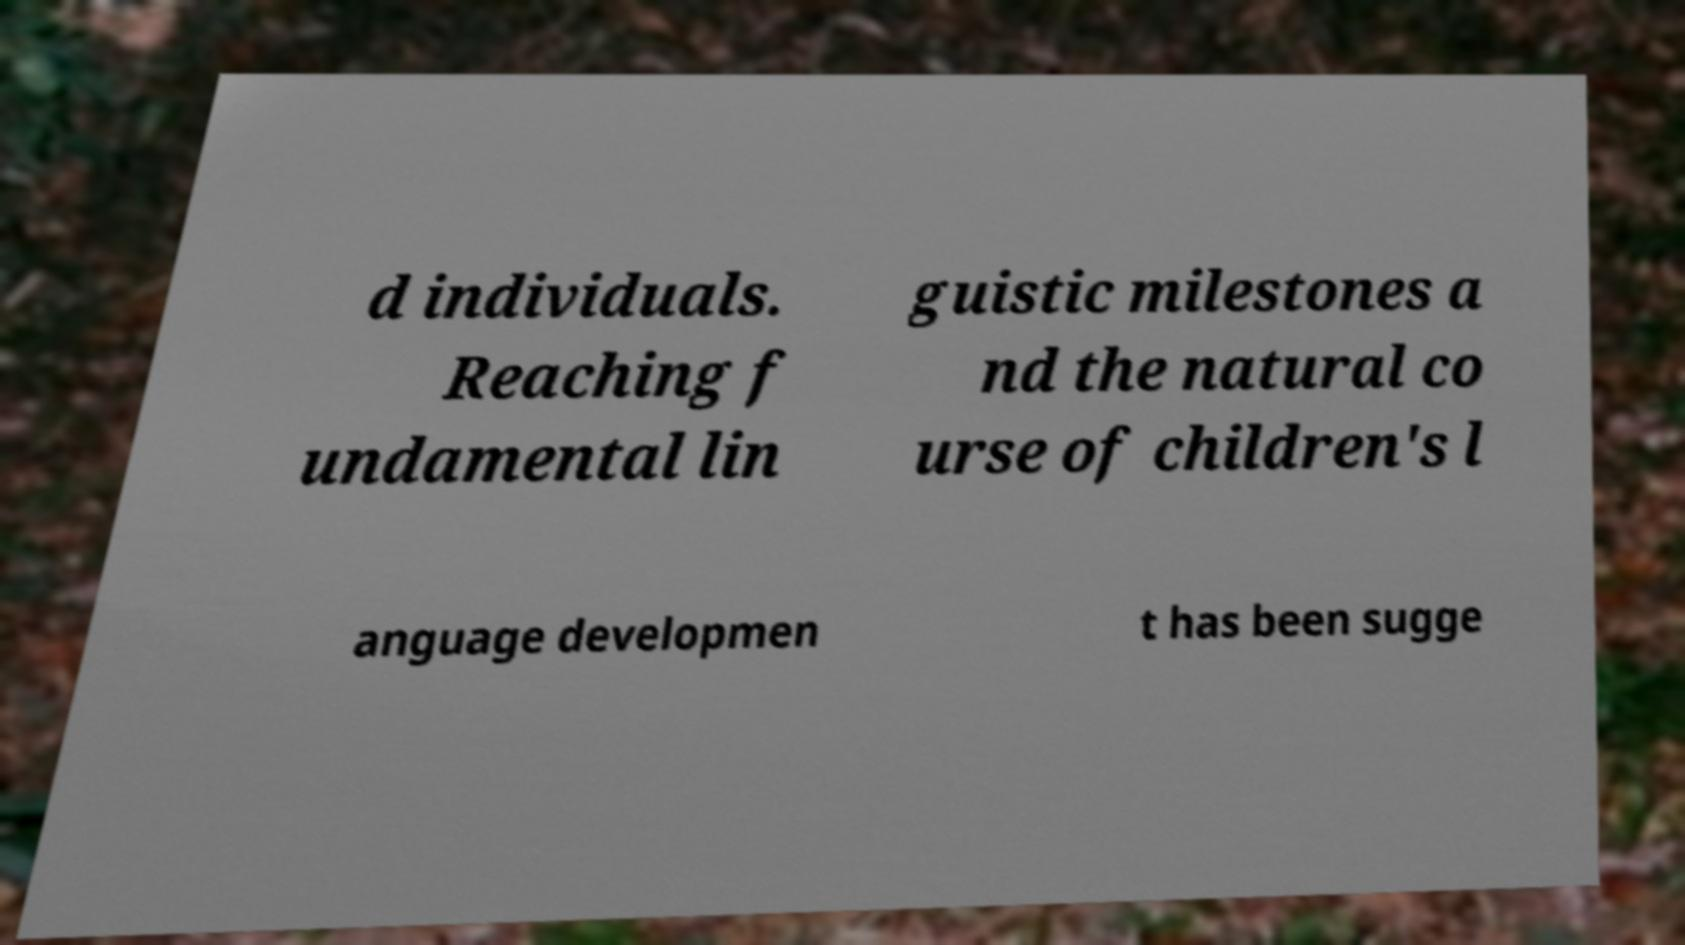There's text embedded in this image that I need extracted. Can you transcribe it verbatim? d individuals. Reaching f undamental lin guistic milestones a nd the natural co urse of children's l anguage developmen t has been sugge 